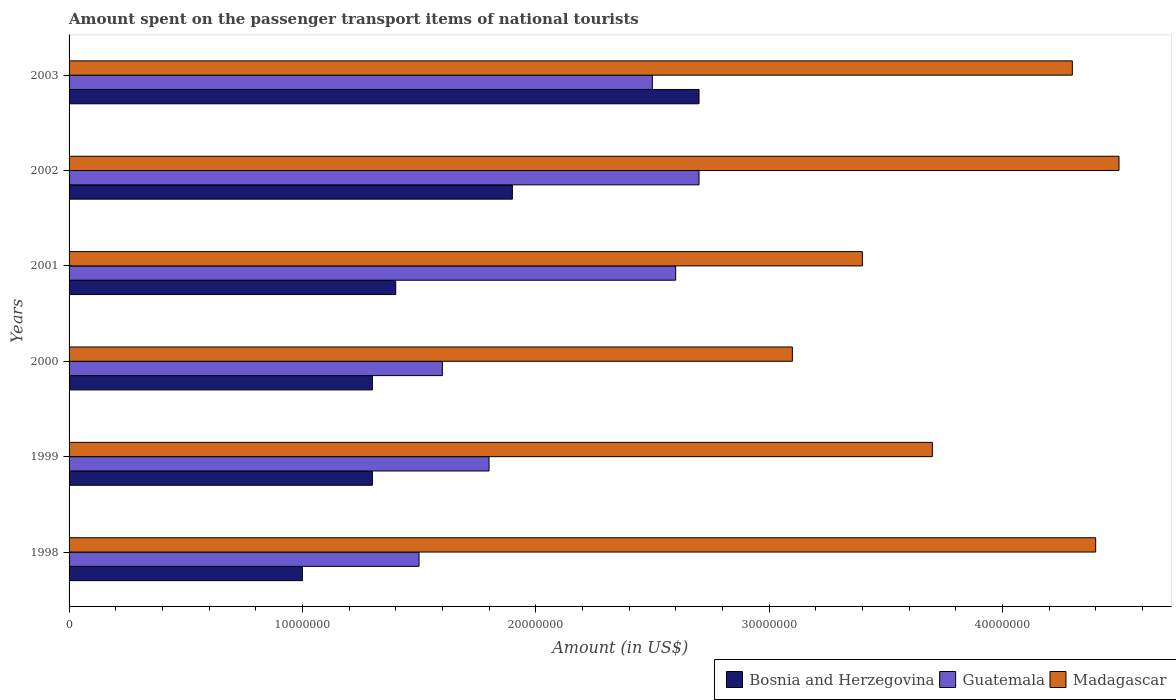How many different coloured bars are there?
Make the answer very short. 3. How many bars are there on the 2nd tick from the bottom?
Offer a very short reply. 3. What is the amount spent on the passenger transport items of national tourists in Bosnia and Herzegovina in 2003?
Your response must be concise. 2.70e+07. Across all years, what is the maximum amount spent on the passenger transport items of national tourists in Guatemala?
Make the answer very short. 2.70e+07. Across all years, what is the minimum amount spent on the passenger transport items of national tourists in Guatemala?
Offer a terse response. 1.50e+07. In which year was the amount spent on the passenger transport items of national tourists in Bosnia and Herzegovina minimum?
Offer a very short reply. 1998. What is the total amount spent on the passenger transport items of national tourists in Bosnia and Herzegovina in the graph?
Keep it short and to the point. 9.60e+07. What is the difference between the amount spent on the passenger transport items of national tourists in Bosnia and Herzegovina in 2001 and the amount spent on the passenger transport items of national tourists in Guatemala in 2003?
Give a very brief answer. -1.10e+07. What is the average amount spent on the passenger transport items of national tourists in Guatemala per year?
Give a very brief answer. 2.12e+07. In the year 2001, what is the difference between the amount spent on the passenger transport items of national tourists in Guatemala and amount spent on the passenger transport items of national tourists in Madagascar?
Your answer should be compact. -8.00e+06. What is the ratio of the amount spent on the passenger transport items of national tourists in Guatemala in 2000 to that in 2002?
Make the answer very short. 0.59. Is the amount spent on the passenger transport items of national tourists in Guatemala in 2000 less than that in 2002?
Give a very brief answer. Yes. What is the difference between the highest and the lowest amount spent on the passenger transport items of national tourists in Bosnia and Herzegovina?
Your answer should be compact. 1.70e+07. Is the sum of the amount spent on the passenger transport items of national tourists in Bosnia and Herzegovina in 2002 and 2003 greater than the maximum amount spent on the passenger transport items of national tourists in Guatemala across all years?
Ensure brevity in your answer.  Yes. What does the 3rd bar from the top in 2003 represents?
Offer a terse response. Bosnia and Herzegovina. What does the 2nd bar from the bottom in 2003 represents?
Your answer should be compact. Guatemala. Are all the bars in the graph horizontal?
Ensure brevity in your answer.  Yes. How many years are there in the graph?
Provide a short and direct response. 6. Does the graph contain any zero values?
Your answer should be very brief. No. Does the graph contain grids?
Provide a succinct answer. No. Where does the legend appear in the graph?
Your answer should be very brief. Bottom right. What is the title of the graph?
Keep it short and to the point. Amount spent on the passenger transport items of national tourists. What is the label or title of the X-axis?
Offer a very short reply. Amount (in US$). What is the label or title of the Y-axis?
Keep it short and to the point. Years. What is the Amount (in US$) of Bosnia and Herzegovina in 1998?
Give a very brief answer. 1.00e+07. What is the Amount (in US$) of Guatemala in 1998?
Your answer should be very brief. 1.50e+07. What is the Amount (in US$) in Madagascar in 1998?
Keep it short and to the point. 4.40e+07. What is the Amount (in US$) of Bosnia and Herzegovina in 1999?
Provide a succinct answer. 1.30e+07. What is the Amount (in US$) in Guatemala in 1999?
Provide a succinct answer. 1.80e+07. What is the Amount (in US$) of Madagascar in 1999?
Provide a short and direct response. 3.70e+07. What is the Amount (in US$) in Bosnia and Herzegovina in 2000?
Give a very brief answer. 1.30e+07. What is the Amount (in US$) in Guatemala in 2000?
Provide a short and direct response. 1.60e+07. What is the Amount (in US$) in Madagascar in 2000?
Offer a terse response. 3.10e+07. What is the Amount (in US$) of Bosnia and Herzegovina in 2001?
Offer a very short reply. 1.40e+07. What is the Amount (in US$) in Guatemala in 2001?
Offer a terse response. 2.60e+07. What is the Amount (in US$) in Madagascar in 2001?
Make the answer very short. 3.40e+07. What is the Amount (in US$) in Bosnia and Herzegovina in 2002?
Provide a succinct answer. 1.90e+07. What is the Amount (in US$) in Guatemala in 2002?
Your answer should be compact. 2.70e+07. What is the Amount (in US$) of Madagascar in 2002?
Your response must be concise. 4.50e+07. What is the Amount (in US$) of Bosnia and Herzegovina in 2003?
Keep it short and to the point. 2.70e+07. What is the Amount (in US$) of Guatemala in 2003?
Make the answer very short. 2.50e+07. What is the Amount (in US$) in Madagascar in 2003?
Offer a terse response. 4.30e+07. Across all years, what is the maximum Amount (in US$) of Bosnia and Herzegovina?
Keep it short and to the point. 2.70e+07. Across all years, what is the maximum Amount (in US$) in Guatemala?
Provide a succinct answer. 2.70e+07. Across all years, what is the maximum Amount (in US$) of Madagascar?
Provide a short and direct response. 4.50e+07. Across all years, what is the minimum Amount (in US$) in Bosnia and Herzegovina?
Your response must be concise. 1.00e+07. Across all years, what is the minimum Amount (in US$) in Guatemala?
Your answer should be very brief. 1.50e+07. Across all years, what is the minimum Amount (in US$) in Madagascar?
Offer a terse response. 3.10e+07. What is the total Amount (in US$) of Bosnia and Herzegovina in the graph?
Ensure brevity in your answer.  9.60e+07. What is the total Amount (in US$) in Guatemala in the graph?
Make the answer very short. 1.27e+08. What is the total Amount (in US$) of Madagascar in the graph?
Your answer should be very brief. 2.34e+08. What is the difference between the Amount (in US$) in Guatemala in 1998 and that in 1999?
Provide a short and direct response. -3.00e+06. What is the difference between the Amount (in US$) in Bosnia and Herzegovina in 1998 and that in 2000?
Offer a very short reply. -3.00e+06. What is the difference between the Amount (in US$) in Guatemala in 1998 and that in 2000?
Ensure brevity in your answer.  -1.00e+06. What is the difference between the Amount (in US$) of Madagascar in 1998 and that in 2000?
Give a very brief answer. 1.30e+07. What is the difference between the Amount (in US$) in Guatemala in 1998 and that in 2001?
Provide a short and direct response. -1.10e+07. What is the difference between the Amount (in US$) in Madagascar in 1998 and that in 2001?
Provide a succinct answer. 1.00e+07. What is the difference between the Amount (in US$) of Bosnia and Herzegovina in 1998 and that in 2002?
Offer a terse response. -9.00e+06. What is the difference between the Amount (in US$) in Guatemala in 1998 and that in 2002?
Offer a terse response. -1.20e+07. What is the difference between the Amount (in US$) in Bosnia and Herzegovina in 1998 and that in 2003?
Give a very brief answer. -1.70e+07. What is the difference between the Amount (in US$) in Guatemala in 1998 and that in 2003?
Your answer should be very brief. -1.00e+07. What is the difference between the Amount (in US$) of Madagascar in 1999 and that in 2000?
Provide a short and direct response. 6.00e+06. What is the difference between the Amount (in US$) in Bosnia and Herzegovina in 1999 and that in 2001?
Give a very brief answer. -1.00e+06. What is the difference between the Amount (in US$) in Guatemala in 1999 and that in 2001?
Your answer should be very brief. -8.00e+06. What is the difference between the Amount (in US$) of Madagascar in 1999 and that in 2001?
Offer a terse response. 3.00e+06. What is the difference between the Amount (in US$) of Bosnia and Herzegovina in 1999 and that in 2002?
Give a very brief answer. -6.00e+06. What is the difference between the Amount (in US$) of Guatemala in 1999 and that in 2002?
Your answer should be very brief. -9.00e+06. What is the difference between the Amount (in US$) of Madagascar in 1999 and that in 2002?
Your response must be concise. -8.00e+06. What is the difference between the Amount (in US$) in Bosnia and Herzegovina in 1999 and that in 2003?
Provide a succinct answer. -1.40e+07. What is the difference between the Amount (in US$) in Guatemala in 1999 and that in 2003?
Your response must be concise. -7.00e+06. What is the difference between the Amount (in US$) in Madagascar in 1999 and that in 2003?
Provide a succinct answer. -6.00e+06. What is the difference between the Amount (in US$) of Guatemala in 2000 and that in 2001?
Give a very brief answer. -1.00e+07. What is the difference between the Amount (in US$) of Madagascar in 2000 and that in 2001?
Offer a terse response. -3.00e+06. What is the difference between the Amount (in US$) in Bosnia and Herzegovina in 2000 and that in 2002?
Ensure brevity in your answer.  -6.00e+06. What is the difference between the Amount (in US$) in Guatemala in 2000 and that in 2002?
Give a very brief answer. -1.10e+07. What is the difference between the Amount (in US$) of Madagascar in 2000 and that in 2002?
Provide a succinct answer. -1.40e+07. What is the difference between the Amount (in US$) in Bosnia and Herzegovina in 2000 and that in 2003?
Offer a very short reply. -1.40e+07. What is the difference between the Amount (in US$) in Guatemala in 2000 and that in 2003?
Your response must be concise. -9.00e+06. What is the difference between the Amount (in US$) of Madagascar in 2000 and that in 2003?
Offer a very short reply. -1.20e+07. What is the difference between the Amount (in US$) in Bosnia and Herzegovina in 2001 and that in 2002?
Provide a succinct answer. -5.00e+06. What is the difference between the Amount (in US$) of Guatemala in 2001 and that in 2002?
Your answer should be very brief. -1.00e+06. What is the difference between the Amount (in US$) in Madagascar in 2001 and that in 2002?
Provide a short and direct response. -1.10e+07. What is the difference between the Amount (in US$) of Bosnia and Herzegovina in 2001 and that in 2003?
Offer a terse response. -1.30e+07. What is the difference between the Amount (in US$) in Guatemala in 2001 and that in 2003?
Ensure brevity in your answer.  1.00e+06. What is the difference between the Amount (in US$) of Madagascar in 2001 and that in 2003?
Provide a succinct answer. -9.00e+06. What is the difference between the Amount (in US$) in Bosnia and Herzegovina in 2002 and that in 2003?
Your answer should be very brief. -8.00e+06. What is the difference between the Amount (in US$) of Madagascar in 2002 and that in 2003?
Offer a very short reply. 2.00e+06. What is the difference between the Amount (in US$) in Bosnia and Herzegovina in 1998 and the Amount (in US$) in Guatemala in 1999?
Provide a succinct answer. -8.00e+06. What is the difference between the Amount (in US$) in Bosnia and Herzegovina in 1998 and the Amount (in US$) in Madagascar in 1999?
Keep it short and to the point. -2.70e+07. What is the difference between the Amount (in US$) of Guatemala in 1998 and the Amount (in US$) of Madagascar in 1999?
Your answer should be compact. -2.20e+07. What is the difference between the Amount (in US$) in Bosnia and Herzegovina in 1998 and the Amount (in US$) in Guatemala in 2000?
Your answer should be compact. -6.00e+06. What is the difference between the Amount (in US$) in Bosnia and Herzegovina in 1998 and the Amount (in US$) in Madagascar in 2000?
Offer a terse response. -2.10e+07. What is the difference between the Amount (in US$) of Guatemala in 1998 and the Amount (in US$) of Madagascar in 2000?
Provide a succinct answer. -1.60e+07. What is the difference between the Amount (in US$) of Bosnia and Herzegovina in 1998 and the Amount (in US$) of Guatemala in 2001?
Keep it short and to the point. -1.60e+07. What is the difference between the Amount (in US$) of Bosnia and Herzegovina in 1998 and the Amount (in US$) of Madagascar in 2001?
Provide a short and direct response. -2.40e+07. What is the difference between the Amount (in US$) in Guatemala in 1998 and the Amount (in US$) in Madagascar in 2001?
Offer a very short reply. -1.90e+07. What is the difference between the Amount (in US$) of Bosnia and Herzegovina in 1998 and the Amount (in US$) of Guatemala in 2002?
Offer a terse response. -1.70e+07. What is the difference between the Amount (in US$) in Bosnia and Herzegovina in 1998 and the Amount (in US$) in Madagascar in 2002?
Provide a succinct answer. -3.50e+07. What is the difference between the Amount (in US$) of Guatemala in 1998 and the Amount (in US$) of Madagascar in 2002?
Your answer should be very brief. -3.00e+07. What is the difference between the Amount (in US$) of Bosnia and Herzegovina in 1998 and the Amount (in US$) of Guatemala in 2003?
Your answer should be very brief. -1.50e+07. What is the difference between the Amount (in US$) in Bosnia and Herzegovina in 1998 and the Amount (in US$) in Madagascar in 2003?
Your answer should be compact. -3.30e+07. What is the difference between the Amount (in US$) in Guatemala in 1998 and the Amount (in US$) in Madagascar in 2003?
Provide a short and direct response. -2.80e+07. What is the difference between the Amount (in US$) in Bosnia and Herzegovina in 1999 and the Amount (in US$) in Guatemala in 2000?
Give a very brief answer. -3.00e+06. What is the difference between the Amount (in US$) of Bosnia and Herzegovina in 1999 and the Amount (in US$) of Madagascar in 2000?
Make the answer very short. -1.80e+07. What is the difference between the Amount (in US$) in Guatemala in 1999 and the Amount (in US$) in Madagascar in 2000?
Provide a succinct answer. -1.30e+07. What is the difference between the Amount (in US$) of Bosnia and Herzegovina in 1999 and the Amount (in US$) of Guatemala in 2001?
Provide a succinct answer. -1.30e+07. What is the difference between the Amount (in US$) in Bosnia and Herzegovina in 1999 and the Amount (in US$) in Madagascar in 2001?
Offer a terse response. -2.10e+07. What is the difference between the Amount (in US$) of Guatemala in 1999 and the Amount (in US$) of Madagascar in 2001?
Offer a very short reply. -1.60e+07. What is the difference between the Amount (in US$) in Bosnia and Herzegovina in 1999 and the Amount (in US$) in Guatemala in 2002?
Keep it short and to the point. -1.40e+07. What is the difference between the Amount (in US$) of Bosnia and Herzegovina in 1999 and the Amount (in US$) of Madagascar in 2002?
Offer a very short reply. -3.20e+07. What is the difference between the Amount (in US$) in Guatemala in 1999 and the Amount (in US$) in Madagascar in 2002?
Ensure brevity in your answer.  -2.70e+07. What is the difference between the Amount (in US$) of Bosnia and Herzegovina in 1999 and the Amount (in US$) of Guatemala in 2003?
Offer a terse response. -1.20e+07. What is the difference between the Amount (in US$) of Bosnia and Herzegovina in 1999 and the Amount (in US$) of Madagascar in 2003?
Offer a terse response. -3.00e+07. What is the difference between the Amount (in US$) in Guatemala in 1999 and the Amount (in US$) in Madagascar in 2003?
Provide a short and direct response. -2.50e+07. What is the difference between the Amount (in US$) in Bosnia and Herzegovina in 2000 and the Amount (in US$) in Guatemala in 2001?
Ensure brevity in your answer.  -1.30e+07. What is the difference between the Amount (in US$) of Bosnia and Herzegovina in 2000 and the Amount (in US$) of Madagascar in 2001?
Your answer should be very brief. -2.10e+07. What is the difference between the Amount (in US$) of Guatemala in 2000 and the Amount (in US$) of Madagascar in 2001?
Provide a short and direct response. -1.80e+07. What is the difference between the Amount (in US$) in Bosnia and Herzegovina in 2000 and the Amount (in US$) in Guatemala in 2002?
Your answer should be very brief. -1.40e+07. What is the difference between the Amount (in US$) in Bosnia and Herzegovina in 2000 and the Amount (in US$) in Madagascar in 2002?
Provide a succinct answer. -3.20e+07. What is the difference between the Amount (in US$) in Guatemala in 2000 and the Amount (in US$) in Madagascar in 2002?
Provide a succinct answer. -2.90e+07. What is the difference between the Amount (in US$) of Bosnia and Herzegovina in 2000 and the Amount (in US$) of Guatemala in 2003?
Provide a succinct answer. -1.20e+07. What is the difference between the Amount (in US$) of Bosnia and Herzegovina in 2000 and the Amount (in US$) of Madagascar in 2003?
Provide a succinct answer. -3.00e+07. What is the difference between the Amount (in US$) of Guatemala in 2000 and the Amount (in US$) of Madagascar in 2003?
Provide a succinct answer. -2.70e+07. What is the difference between the Amount (in US$) in Bosnia and Herzegovina in 2001 and the Amount (in US$) in Guatemala in 2002?
Ensure brevity in your answer.  -1.30e+07. What is the difference between the Amount (in US$) in Bosnia and Herzegovina in 2001 and the Amount (in US$) in Madagascar in 2002?
Your answer should be compact. -3.10e+07. What is the difference between the Amount (in US$) of Guatemala in 2001 and the Amount (in US$) of Madagascar in 2002?
Your answer should be very brief. -1.90e+07. What is the difference between the Amount (in US$) of Bosnia and Herzegovina in 2001 and the Amount (in US$) of Guatemala in 2003?
Your answer should be compact. -1.10e+07. What is the difference between the Amount (in US$) of Bosnia and Herzegovina in 2001 and the Amount (in US$) of Madagascar in 2003?
Provide a short and direct response. -2.90e+07. What is the difference between the Amount (in US$) of Guatemala in 2001 and the Amount (in US$) of Madagascar in 2003?
Your answer should be compact. -1.70e+07. What is the difference between the Amount (in US$) in Bosnia and Herzegovina in 2002 and the Amount (in US$) in Guatemala in 2003?
Your answer should be very brief. -6.00e+06. What is the difference between the Amount (in US$) of Bosnia and Herzegovina in 2002 and the Amount (in US$) of Madagascar in 2003?
Make the answer very short. -2.40e+07. What is the difference between the Amount (in US$) of Guatemala in 2002 and the Amount (in US$) of Madagascar in 2003?
Offer a very short reply. -1.60e+07. What is the average Amount (in US$) in Bosnia and Herzegovina per year?
Offer a very short reply. 1.60e+07. What is the average Amount (in US$) in Guatemala per year?
Provide a short and direct response. 2.12e+07. What is the average Amount (in US$) in Madagascar per year?
Your response must be concise. 3.90e+07. In the year 1998, what is the difference between the Amount (in US$) in Bosnia and Herzegovina and Amount (in US$) in Guatemala?
Offer a very short reply. -5.00e+06. In the year 1998, what is the difference between the Amount (in US$) of Bosnia and Herzegovina and Amount (in US$) of Madagascar?
Provide a succinct answer. -3.40e+07. In the year 1998, what is the difference between the Amount (in US$) of Guatemala and Amount (in US$) of Madagascar?
Offer a terse response. -2.90e+07. In the year 1999, what is the difference between the Amount (in US$) in Bosnia and Herzegovina and Amount (in US$) in Guatemala?
Make the answer very short. -5.00e+06. In the year 1999, what is the difference between the Amount (in US$) of Bosnia and Herzegovina and Amount (in US$) of Madagascar?
Your response must be concise. -2.40e+07. In the year 1999, what is the difference between the Amount (in US$) in Guatemala and Amount (in US$) in Madagascar?
Keep it short and to the point. -1.90e+07. In the year 2000, what is the difference between the Amount (in US$) in Bosnia and Herzegovina and Amount (in US$) in Guatemala?
Provide a succinct answer. -3.00e+06. In the year 2000, what is the difference between the Amount (in US$) in Bosnia and Herzegovina and Amount (in US$) in Madagascar?
Your answer should be compact. -1.80e+07. In the year 2000, what is the difference between the Amount (in US$) of Guatemala and Amount (in US$) of Madagascar?
Offer a terse response. -1.50e+07. In the year 2001, what is the difference between the Amount (in US$) of Bosnia and Herzegovina and Amount (in US$) of Guatemala?
Your answer should be very brief. -1.20e+07. In the year 2001, what is the difference between the Amount (in US$) of Bosnia and Herzegovina and Amount (in US$) of Madagascar?
Your response must be concise. -2.00e+07. In the year 2001, what is the difference between the Amount (in US$) of Guatemala and Amount (in US$) of Madagascar?
Provide a short and direct response. -8.00e+06. In the year 2002, what is the difference between the Amount (in US$) of Bosnia and Herzegovina and Amount (in US$) of Guatemala?
Give a very brief answer. -8.00e+06. In the year 2002, what is the difference between the Amount (in US$) of Bosnia and Herzegovina and Amount (in US$) of Madagascar?
Your answer should be compact. -2.60e+07. In the year 2002, what is the difference between the Amount (in US$) of Guatemala and Amount (in US$) of Madagascar?
Provide a succinct answer. -1.80e+07. In the year 2003, what is the difference between the Amount (in US$) in Bosnia and Herzegovina and Amount (in US$) in Madagascar?
Your response must be concise. -1.60e+07. In the year 2003, what is the difference between the Amount (in US$) of Guatemala and Amount (in US$) of Madagascar?
Give a very brief answer. -1.80e+07. What is the ratio of the Amount (in US$) of Bosnia and Herzegovina in 1998 to that in 1999?
Make the answer very short. 0.77. What is the ratio of the Amount (in US$) in Madagascar in 1998 to that in 1999?
Ensure brevity in your answer.  1.19. What is the ratio of the Amount (in US$) in Bosnia and Herzegovina in 1998 to that in 2000?
Your response must be concise. 0.77. What is the ratio of the Amount (in US$) in Madagascar in 1998 to that in 2000?
Your answer should be very brief. 1.42. What is the ratio of the Amount (in US$) of Guatemala in 1998 to that in 2001?
Make the answer very short. 0.58. What is the ratio of the Amount (in US$) in Madagascar in 1998 to that in 2001?
Your response must be concise. 1.29. What is the ratio of the Amount (in US$) in Bosnia and Herzegovina in 1998 to that in 2002?
Provide a succinct answer. 0.53. What is the ratio of the Amount (in US$) of Guatemala in 1998 to that in 2002?
Ensure brevity in your answer.  0.56. What is the ratio of the Amount (in US$) in Madagascar in 1998 to that in 2002?
Your answer should be compact. 0.98. What is the ratio of the Amount (in US$) of Bosnia and Herzegovina in 1998 to that in 2003?
Give a very brief answer. 0.37. What is the ratio of the Amount (in US$) in Guatemala in 1998 to that in 2003?
Provide a short and direct response. 0.6. What is the ratio of the Amount (in US$) of Madagascar in 1998 to that in 2003?
Your answer should be compact. 1.02. What is the ratio of the Amount (in US$) of Bosnia and Herzegovina in 1999 to that in 2000?
Provide a succinct answer. 1. What is the ratio of the Amount (in US$) in Guatemala in 1999 to that in 2000?
Your response must be concise. 1.12. What is the ratio of the Amount (in US$) of Madagascar in 1999 to that in 2000?
Provide a succinct answer. 1.19. What is the ratio of the Amount (in US$) in Guatemala in 1999 to that in 2001?
Offer a terse response. 0.69. What is the ratio of the Amount (in US$) of Madagascar in 1999 to that in 2001?
Ensure brevity in your answer.  1.09. What is the ratio of the Amount (in US$) in Bosnia and Herzegovina in 1999 to that in 2002?
Ensure brevity in your answer.  0.68. What is the ratio of the Amount (in US$) of Guatemala in 1999 to that in 2002?
Your answer should be very brief. 0.67. What is the ratio of the Amount (in US$) of Madagascar in 1999 to that in 2002?
Ensure brevity in your answer.  0.82. What is the ratio of the Amount (in US$) of Bosnia and Herzegovina in 1999 to that in 2003?
Offer a very short reply. 0.48. What is the ratio of the Amount (in US$) of Guatemala in 1999 to that in 2003?
Provide a succinct answer. 0.72. What is the ratio of the Amount (in US$) of Madagascar in 1999 to that in 2003?
Keep it short and to the point. 0.86. What is the ratio of the Amount (in US$) of Bosnia and Herzegovina in 2000 to that in 2001?
Your answer should be compact. 0.93. What is the ratio of the Amount (in US$) of Guatemala in 2000 to that in 2001?
Ensure brevity in your answer.  0.62. What is the ratio of the Amount (in US$) in Madagascar in 2000 to that in 2001?
Ensure brevity in your answer.  0.91. What is the ratio of the Amount (in US$) in Bosnia and Herzegovina in 2000 to that in 2002?
Offer a terse response. 0.68. What is the ratio of the Amount (in US$) in Guatemala in 2000 to that in 2002?
Give a very brief answer. 0.59. What is the ratio of the Amount (in US$) in Madagascar in 2000 to that in 2002?
Provide a succinct answer. 0.69. What is the ratio of the Amount (in US$) of Bosnia and Herzegovina in 2000 to that in 2003?
Your answer should be compact. 0.48. What is the ratio of the Amount (in US$) of Guatemala in 2000 to that in 2003?
Ensure brevity in your answer.  0.64. What is the ratio of the Amount (in US$) of Madagascar in 2000 to that in 2003?
Offer a very short reply. 0.72. What is the ratio of the Amount (in US$) of Bosnia and Herzegovina in 2001 to that in 2002?
Make the answer very short. 0.74. What is the ratio of the Amount (in US$) of Madagascar in 2001 to that in 2002?
Offer a very short reply. 0.76. What is the ratio of the Amount (in US$) of Bosnia and Herzegovina in 2001 to that in 2003?
Provide a succinct answer. 0.52. What is the ratio of the Amount (in US$) of Guatemala in 2001 to that in 2003?
Give a very brief answer. 1.04. What is the ratio of the Amount (in US$) of Madagascar in 2001 to that in 2003?
Your answer should be very brief. 0.79. What is the ratio of the Amount (in US$) in Bosnia and Herzegovina in 2002 to that in 2003?
Keep it short and to the point. 0.7. What is the ratio of the Amount (in US$) in Madagascar in 2002 to that in 2003?
Ensure brevity in your answer.  1.05. What is the difference between the highest and the second highest Amount (in US$) of Bosnia and Herzegovina?
Provide a short and direct response. 8.00e+06. What is the difference between the highest and the second highest Amount (in US$) of Madagascar?
Keep it short and to the point. 1.00e+06. What is the difference between the highest and the lowest Amount (in US$) in Bosnia and Herzegovina?
Offer a terse response. 1.70e+07. What is the difference between the highest and the lowest Amount (in US$) of Madagascar?
Ensure brevity in your answer.  1.40e+07. 